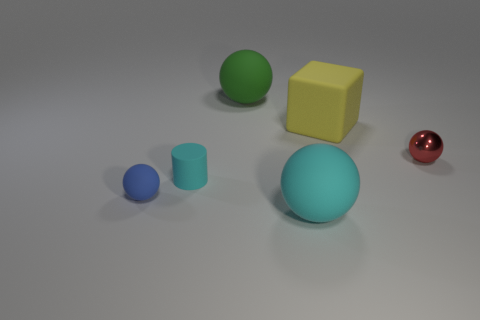What can you infer about the size of these objects in real-world terms? Without additional context, it's challenging to determine the exact size of these objects. However, if we assume the largest object - the cyan sphere - to be roughly the size of a standard basketball, we could estimate the other objects to be smaller in comparison, with diameters less than that of an average ball. 